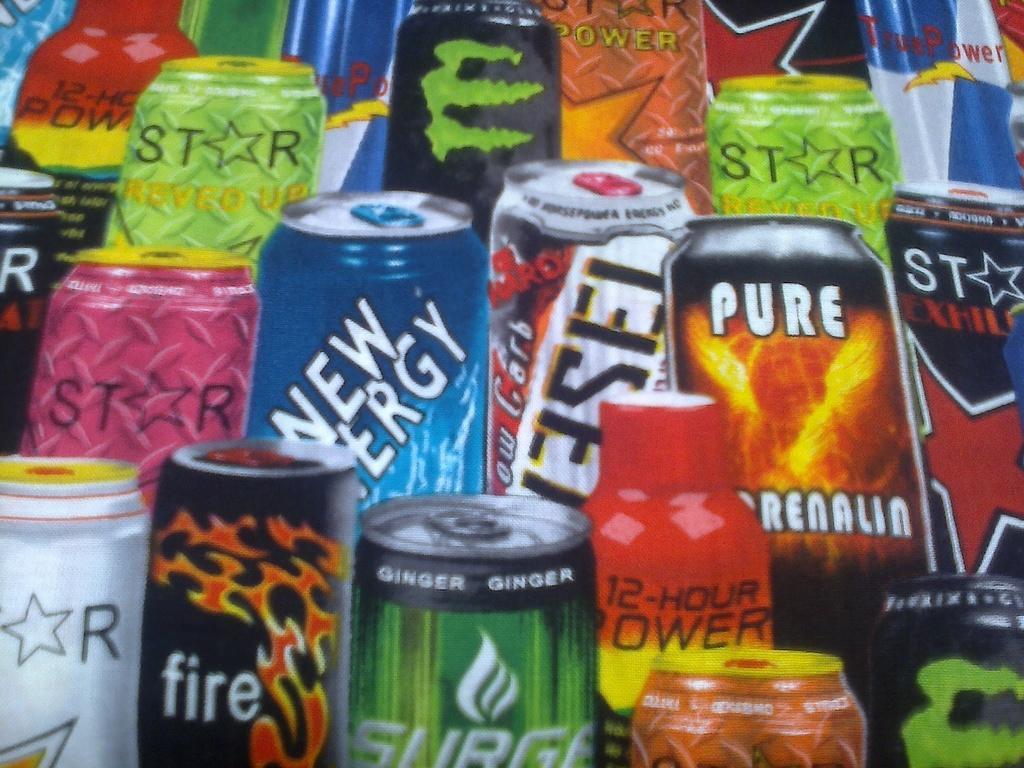Could you give a brief overview of what you see in this image? In this image there are coke cans of different colors. There is some text of each coke can. 